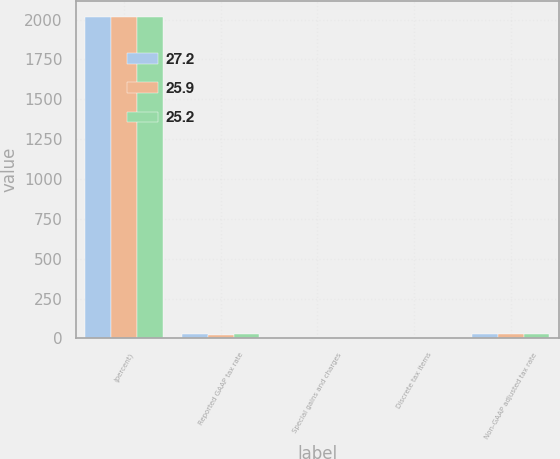Convert chart. <chart><loc_0><loc_0><loc_500><loc_500><stacked_bar_chart><ecel><fcel>(percent)<fcel>Reported GAAP tax rate<fcel>Special gains and charges<fcel>Discrete tax items<fcel>Non-GAAP adjusted tax rate<nl><fcel>27.2<fcel>2016<fcel>24.4<fcel>1<fcel>0.2<fcel>25.2<nl><fcel>25.9<fcel>2015<fcel>22.8<fcel>0.4<fcel>3.5<fcel>25.9<nl><fcel>25.2<fcel>2014<fcel>28<fcel>0.1<fcel>0.7<fcel>27.2<nl></chart> 